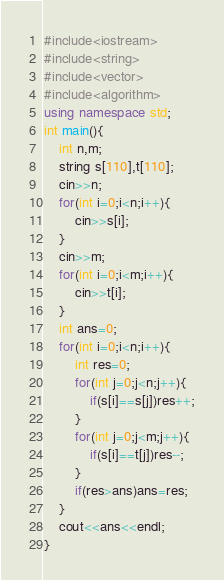<code> <loc_0><loc_0><loc_500><loc_500><_C++_>#include<iostream>
#include<string>
#include<vector>
#include<algorithm>
using namespace std;
int main(){
	int n,m;
	string s[110],t[110];
	cin>>n;
	for(int i=0;i<n;i++){
		cin>>s[i];
	}
	cin>>m;
	for(int i=0;i<m;i++){
		cin>>t[i];
	}
	int ans=0;
	for(int i=0;i<n;i++){
		int res=0;
		for(int j=0;j<n;j++){
			if(s[i]==s[j])res++;
		}
		for(int j=0;j<m;j++){
			if(s[i]==t[j])res--;
		}
		if(res>ans)ans=res;
	}
	cout<<ans<<endl;
}</code> 